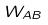Convert formula to latex. <formula><loc_0><loc_0><loc_500><loc_500>W _ { A B }</formula> 